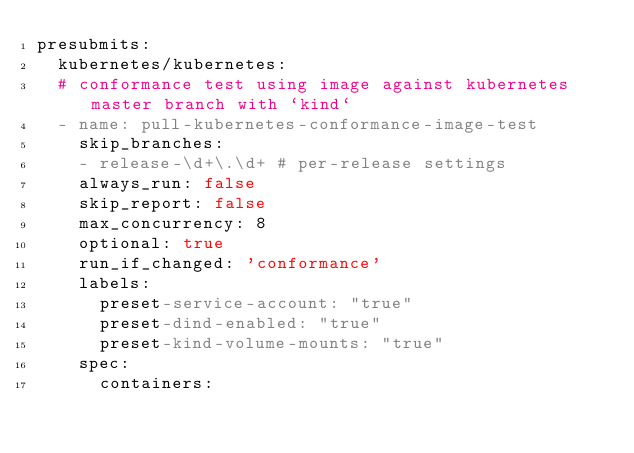Convert code to text. <code><loc_0><loc_0><loc_500><loc_500><_YAML_>presubmits:
  kubernetes/kubernetes:
  # conformance test using image against kubernetes master branch with `kind`
  - name: pull-kubernetes-conformance-image-test
    skip_branches:
    - release-\d+\.\d+ # per-release settings
    always_run: false
    skip_report: false
    max_concurrency: 8
    optional: true
    run_if_changed: 'conformance'
    labels:
      preset-service-account: "true"
      preset-dind-enabled: "true"
      preset-kind-volume-mounts: "true"
    spec:
      containers:</code> 